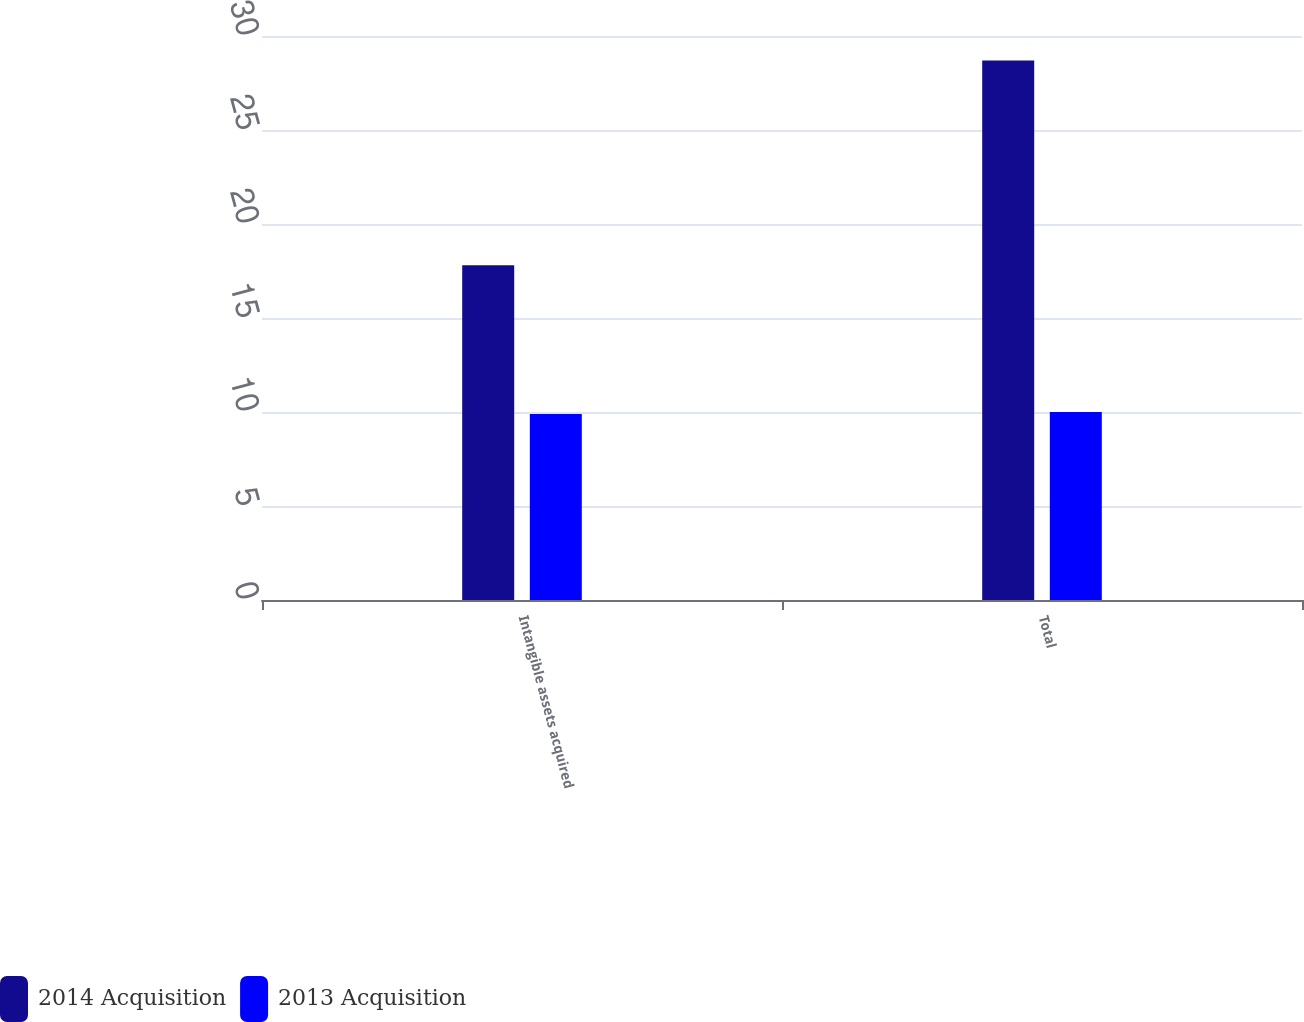<chart> <loc_0><loc_0><loc_500><loc_500><stacked_bar_chart><ecel><fcel>Intangible assets acquired<fcel>Total<nl><fcel>2014 Acquisition<fcel>17.8<fcel>28.7<nl><fcel>2013 Acquisition<fcel>9.9<fcel>10<nl></chart> 